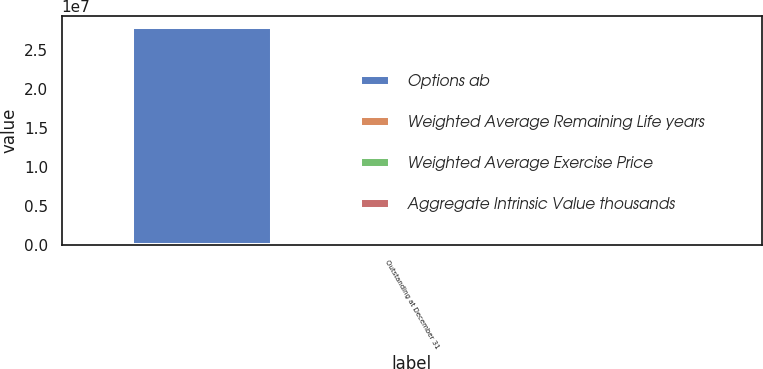Convert chart. <chart><loc_0><loc_0><loc_500><loc_500><stacked_bar_chart><ecel><fcel>Outstanding at December 31<nl><fcel>Options ab<fcel>2.80137e+07<nl><fcel>Weighted Average Remaining Life years<fcel>39.81<nl><fcel>Weighted Average Exercise Price<fcel>4.4<nl><fcel>Aggregate Intrinsic Value thousands<fcel>1115<nl></chart> 